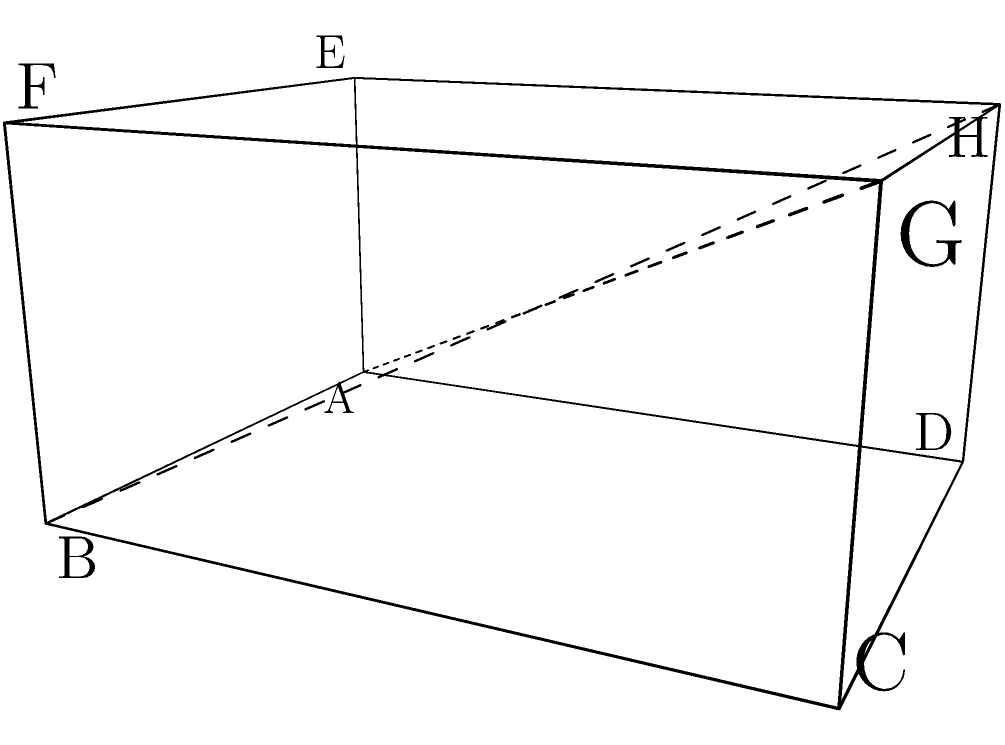In the rectangular prism ABCDEFGH shown above, calculate the angle between the planes ABG and BCG. Express your answer in degrees, rounded to the nearest whole number. To find the angle between two planes, we can use the dot product of their normal vectors. Let's approach this step-by-step:

1) First, we need to find the normal vectors of planes ABG and BCG.

   For plane ABG:
   $\vec{AB} = (3,0,0)$
   $\vec{AG} = (3,4,2)$
   Normal vector $\vec{n_1} = \vec{AB} \times \vec{AG} = (0,-6,12)$

   For plane BCG:
   $\vec{BC} = (0,4,0)$
   $\vec{BG} = (0,4,2)$
   Normal vector $\vec{n_2} = \vec{BC} \times \vec{BG} = (8,0,-12)$

2) Now, we can use the formula for the angle between two vectors:

   $$\cos \theta = \frac{\vec{n_1} \cdot \vec{n_2}}{|\vec{n_1}||\vec{n_2}|}$$

3) Let's calculate each part:
   $\vec{n_1} \cdot \vec{n_2} = 0(-8) + (-6)(0) + (12)(-12) = -144$
   
   $|\vec{n_1}| = \sqrt{0^2 + (-6)^2 + 12^2} = \sqrt{180} = 6\sqrt{5}$
   
   $|\vec{n_2}| = \sqrt{8^2 + 0^2 + (-12)^2} = \sqrt{208} = 4\sqrt{13}$

4) Substituting into the formula:

   $$\cos \theta = \frac{-144}{(6\sqrt{5})(4\sqrt{13})} = \frac{-144}{24\sqrt{65}} = -\frac{6}{\sqrt{65}}$$

5) To get $\theta$, we take the inverse cosine (arccos) of both sides:

   $$\theta = \arccos(-\frac{6}{\sqrt{65}}) \approx 131.41°$$

6) Rounding to the nearest whole number:

   $$\theta \approx 131°$$
Answer: 131° 